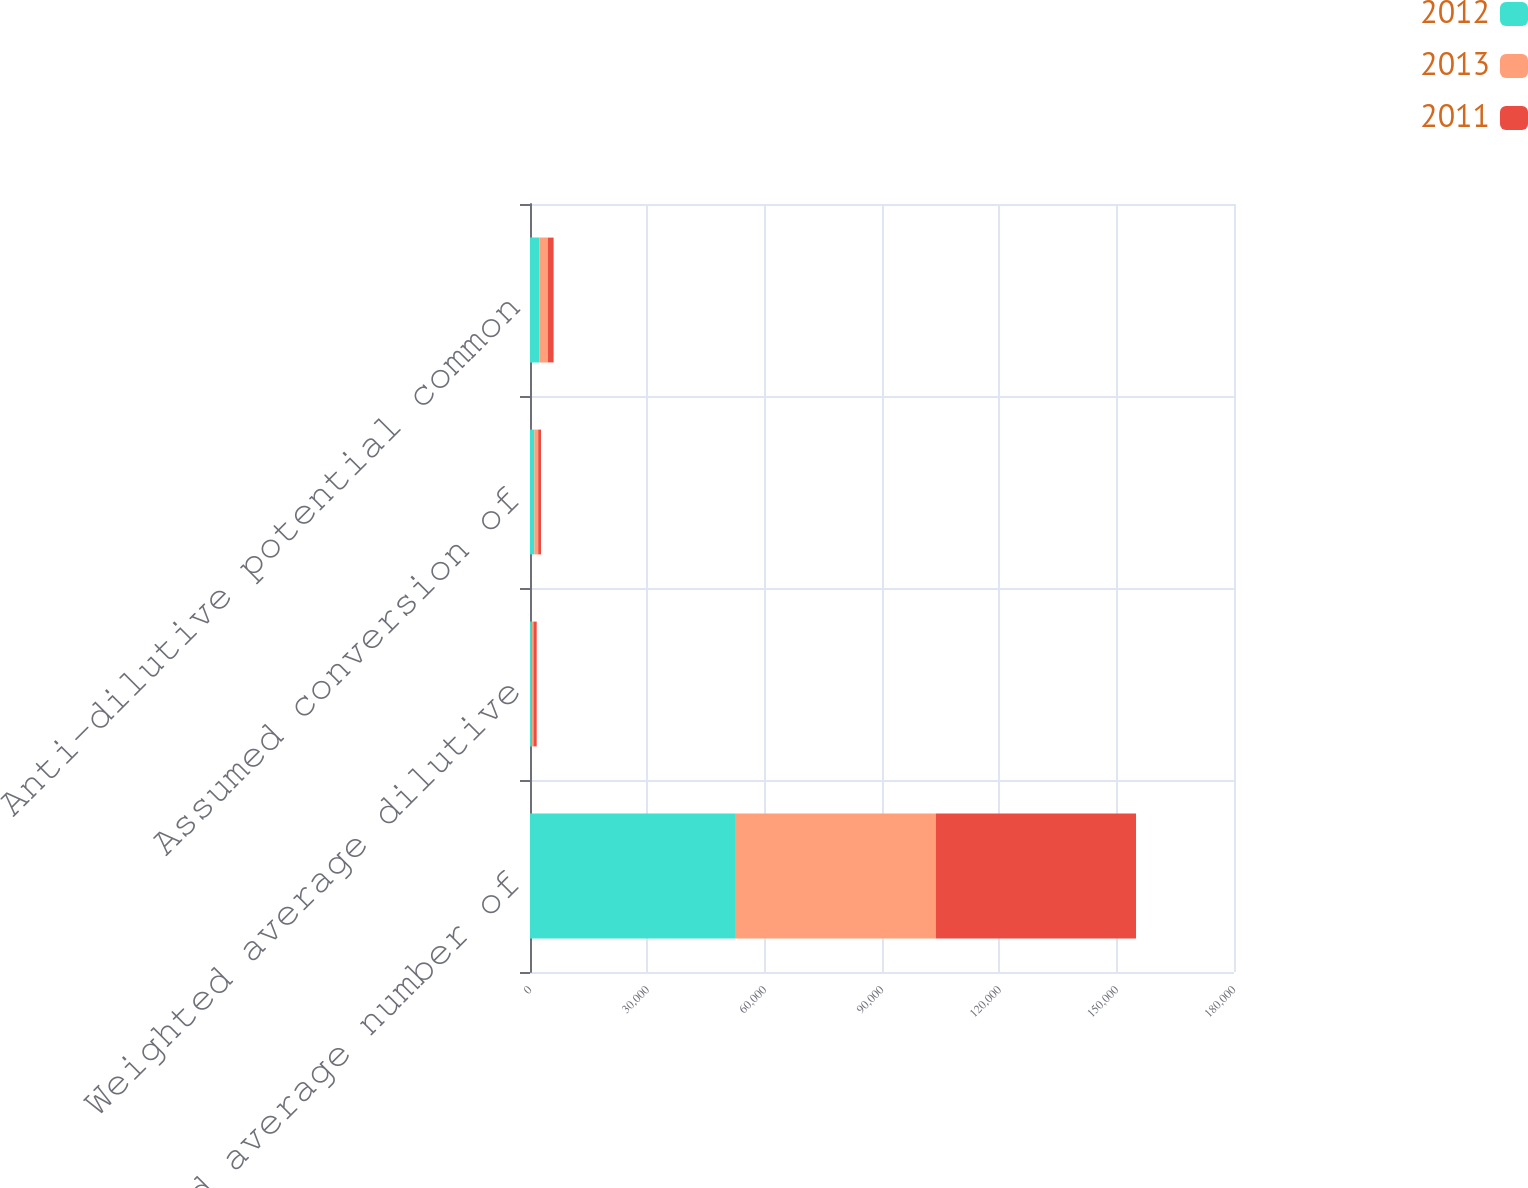Convert chart to OTSL. <chart><loc_0><loc_0><loc_500><loc_500><stacked_bar_chart><ecel><fcel>Weighted average number of<fcel>Weighted average dilutive<fcel>Assumed conversion of<fcel>Anti-dilutive potential common<nl><fcel>2012<fcel>52413<fcel>382<fcel>1107<fcel>2384<nl><fcel>2013<fcel>51326<fcel>501<fcel>985<fcel>2202<nl><fcel>2011<fcel>51211<fcel>828<fcel>729<fcel>1453<nl></chart> 